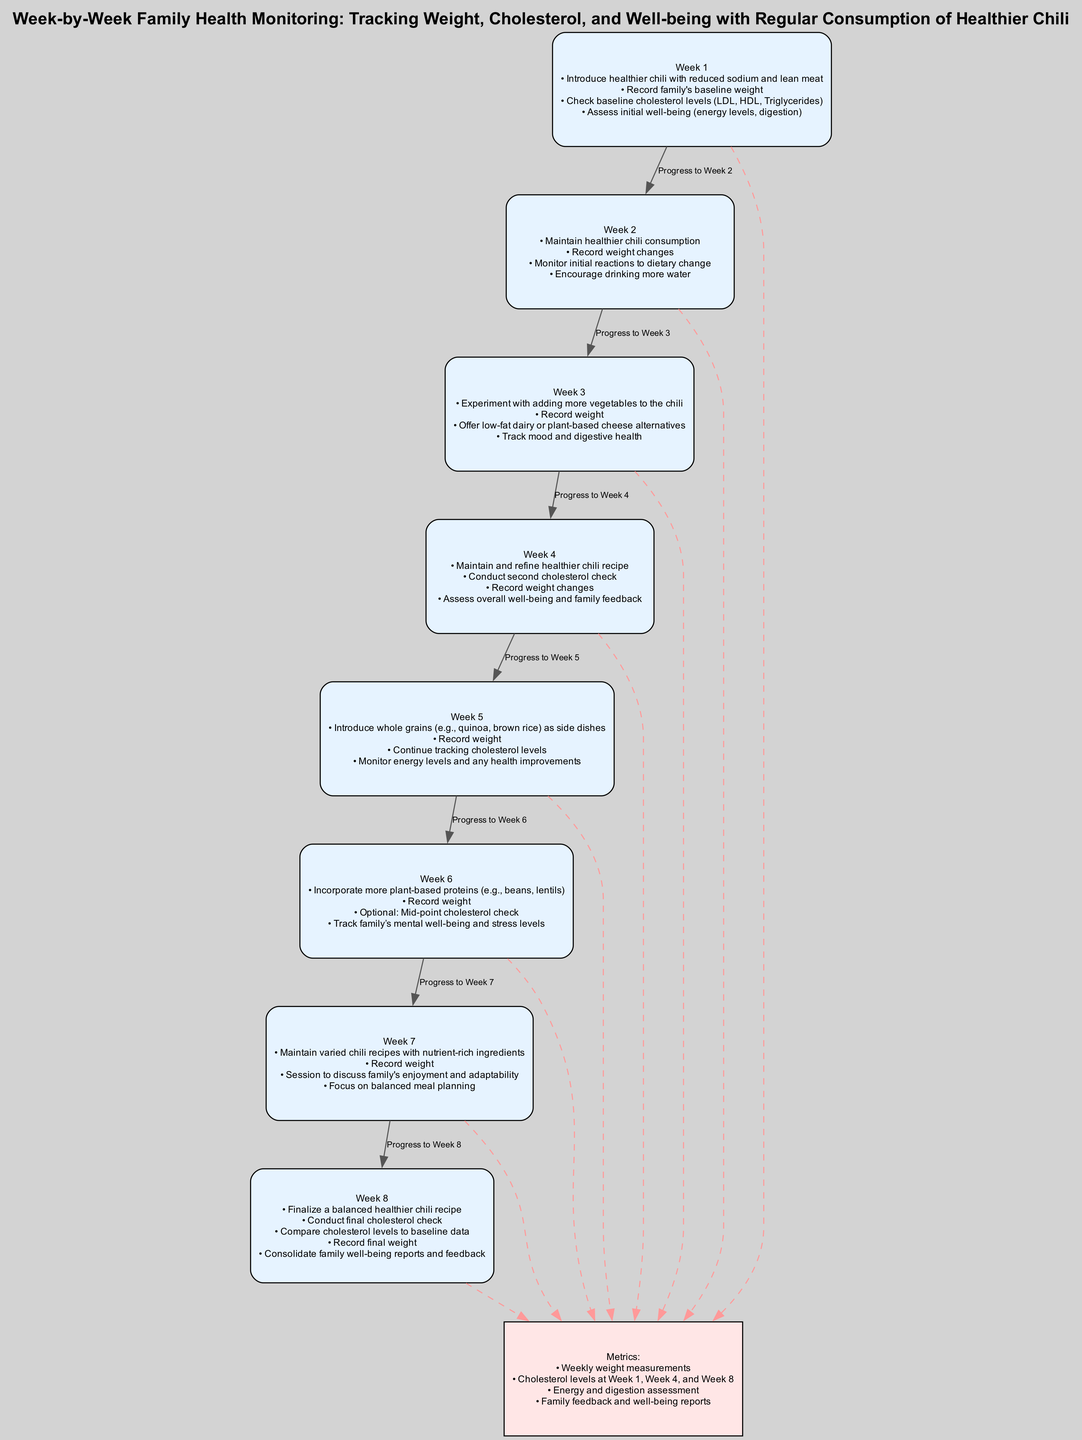What actions are taken in Week 4? In Week 4, the actions include maintaining and refining the healthier chili recipe, conducting a second cholesterol check, recording weight changes, and assessing overall well-being and family feedback. This information is derived directly from the Week 4 node in the diagram where the actions are summarized.
Answer: Maintain and refine healthier chili recipe, conduct second cholesterol check, record weight changes, assess overall well-being and family feedback How many cholesterol checks are conducted throughout the pathway? The diagram shows that cholesterol checks are conducted at Week 1, Week 4, and Week 8, totaling three checks. By counting the cholesterol check actions indicated in the respective weeks, we determine the total.
Answer: 3 Which week includes the introduction of whole grains? Whole grains are introduced as side dishes in Week 5, as stated in the actions for that week within the diagram, highlighting the progression in dietary improvements.
Answer: Week 5 Which week has an action focused on family feedback and enjoyment? The action concerning family feedback and enjoyment is highlighted in Week 7, where there is a session dedicated to discussing the family's enjoyment and adaptability to the chili recipes. This information is drawn from the actions listed for Week 7.
Answer: Week 7 What is the main focus of the metrics node? The metrics node focuses on tracking weekly weight measurements, cholesterol levels at designated weeks, energy and digestion assessments, and consolidating family feedback and well-being reports. This information can be found summarized in the metrics section of the diagram.
Answer: Weekly weight measurements, cholesterol levels, energy and digestion assessment, family feedback and well-being reports What is the final week of the monitoring process? The final week of the monitoring process is Week 8, where key actions include finalizing a balanced healthier chili recipe and conducting a final cholesterol check, as indicated in the week’s actions within the diagram.
Answer: Week 8 Which week is associated with tracking mental well-being and stress levels? Week 6 includes an action focused on tracking the family's mental well-being and stress levels, providing insight into the broader health monitoring that extends beyond physical metrics. This is derived from the actions listed for Week 6 in the diagram.
Answer: Week 6 How does the pathway progress from Week 6 to Week 7? The pathway progresses from Week 6 to Week 7 by maintaining varied chili recipes with nutrient-rich ingredients after tracking additional plant-based proteins and mental well-being in Week 6. The connection is made by following the edges from Week 6 to Week 7 and understanding the logical dietary progression.
Answer: With nutrient-rich ingredients How many total weeks are outlined in the diagram? The total number of weeks outlined in the diagram is 8, as indicated by the nodes labeled from Week 1 through Week 8. This is a straightforward count of the distinct weeks mentioned in the pathway.
Answer: 8 